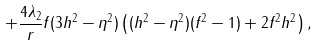<formula> <loc_0><loc_0><loc_500><loc_500>+ \frac { 4 \lambda _ { 2 } } { r } f ( 3 h ^ { 2 } - \eta ^ { 2 } ) \left ( ( h ^ { 2 } - \eta ^ { 2 } ) ( f ^ { 2 } - 1 ) + 2 f ^ { 2 } h ^ { 2 } \right ) ,</formula> 